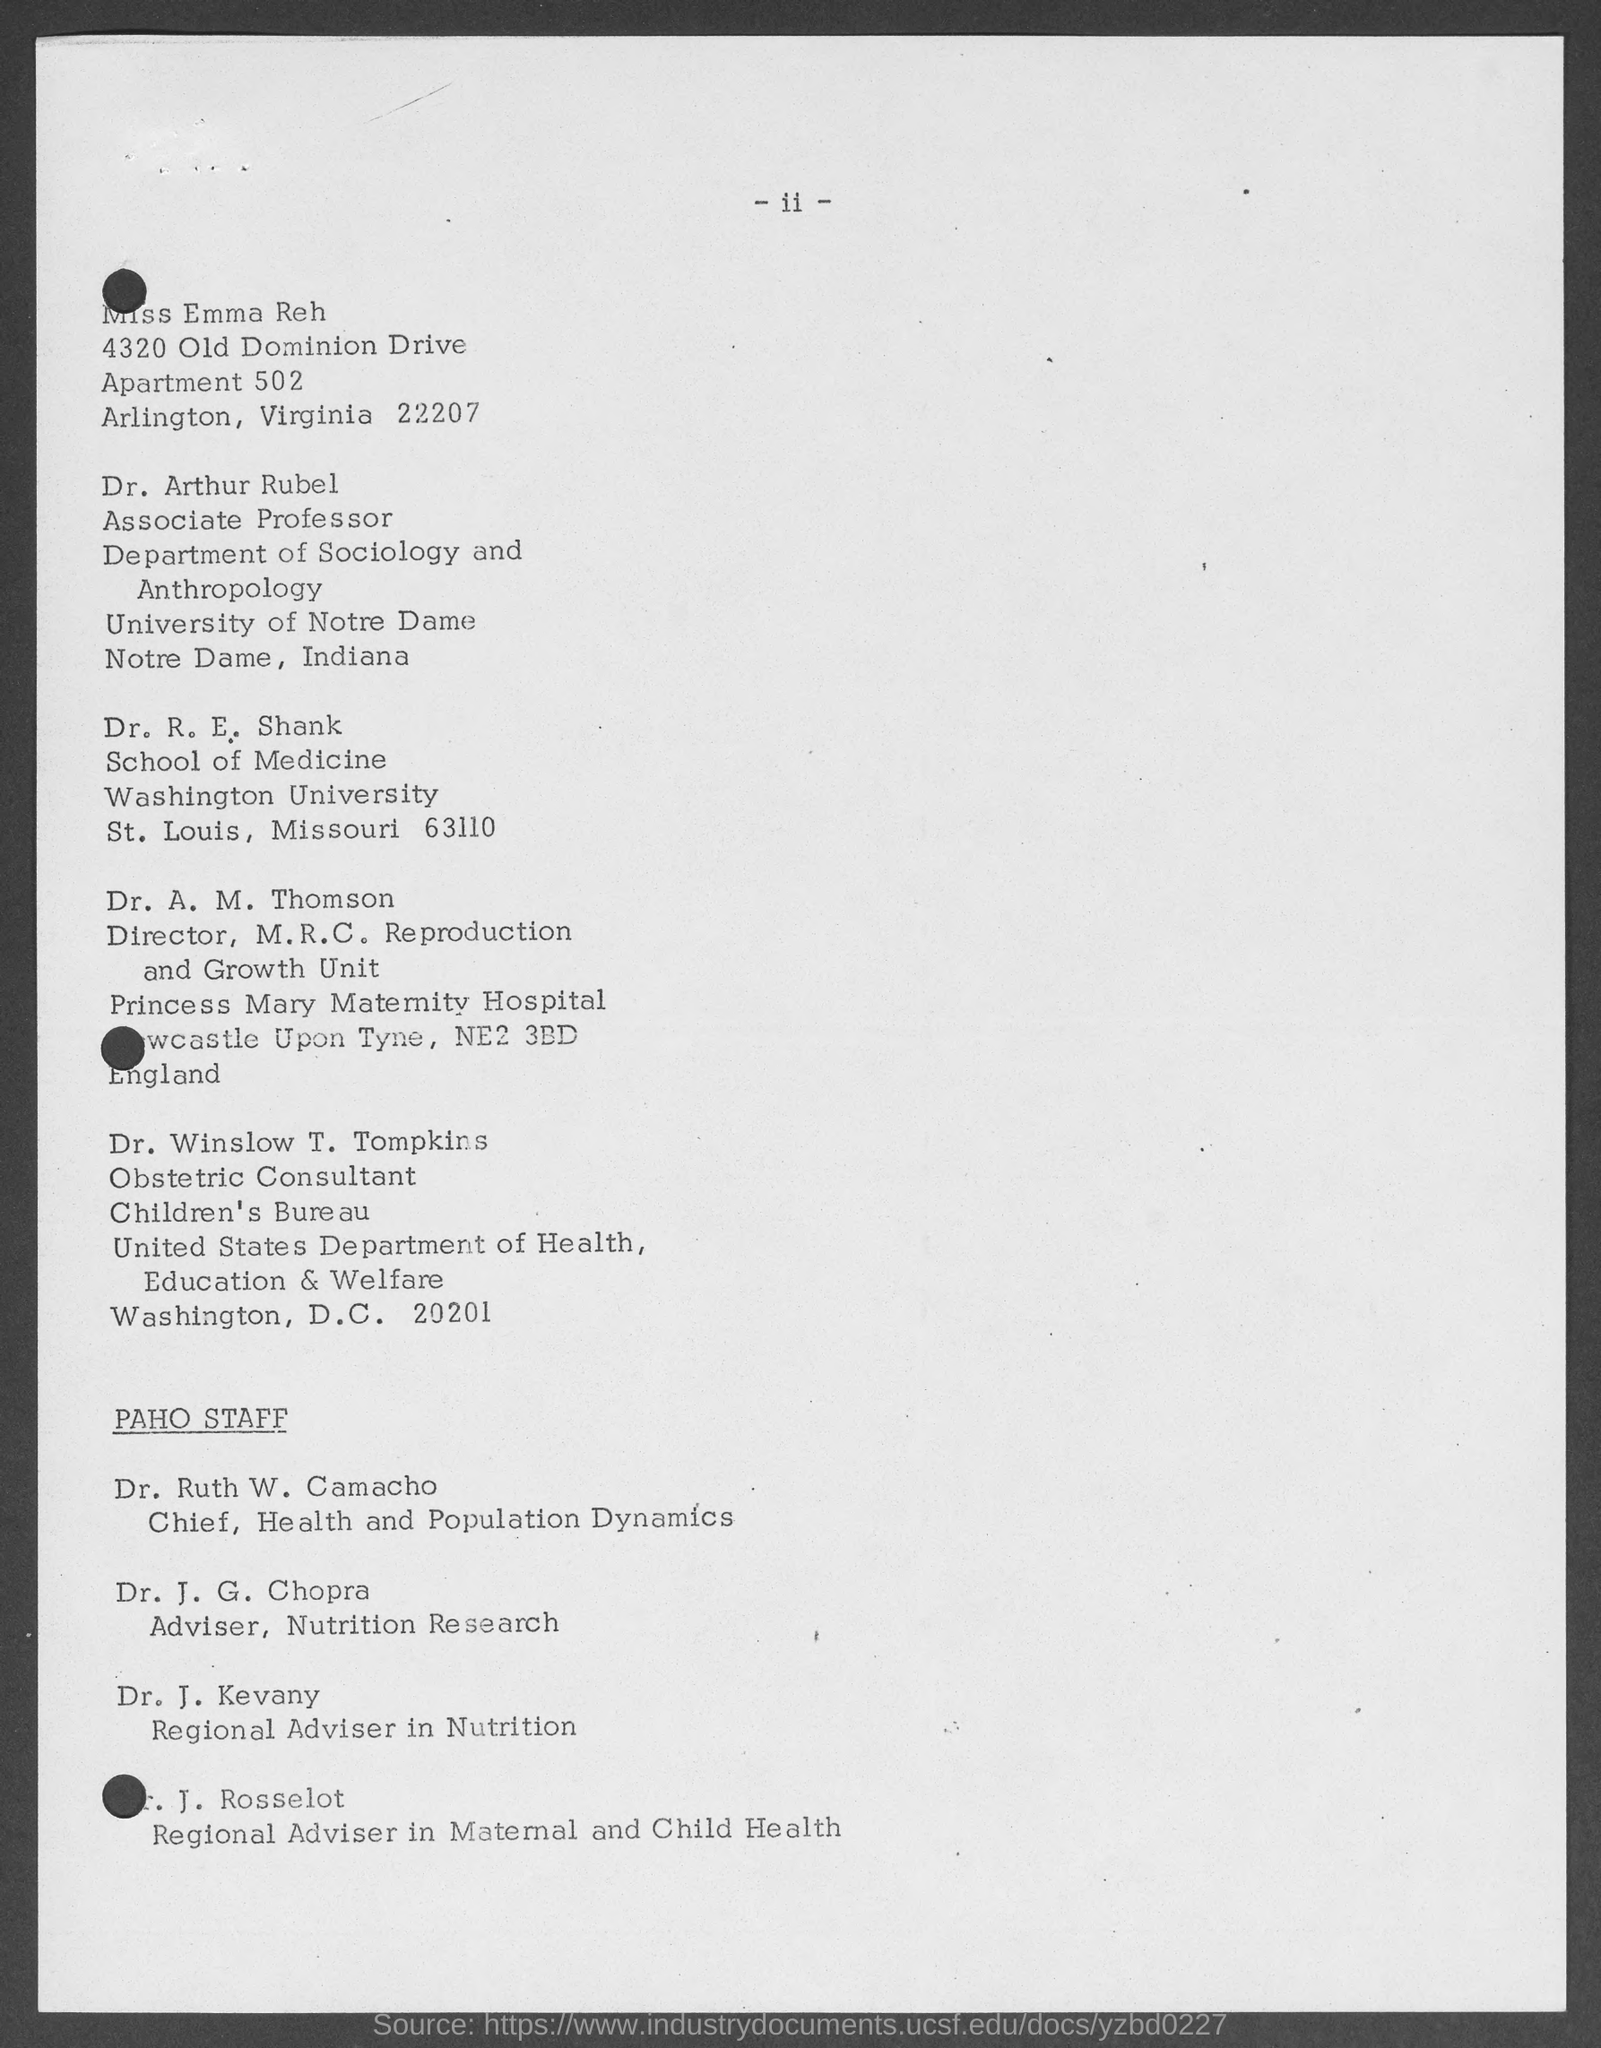What is the designation of Dr. Ruth W. Camacho?
Your answer should be compact. Chief, health and population dynamics. Who is the Regional Adviser in Nutrition?
Your answer should be very brief. Dr. j. kevany. In which University, Dr. R. E. Shank works?
Make the answer very short. Washington university. What is the designation of Dr. J. G. Chopra?
Provide a succinct answer. Adviser, Nutrition Research. In which University, Dr. Arthur Rubel works?
Provide a succinct answer. University of Notre Dame. 